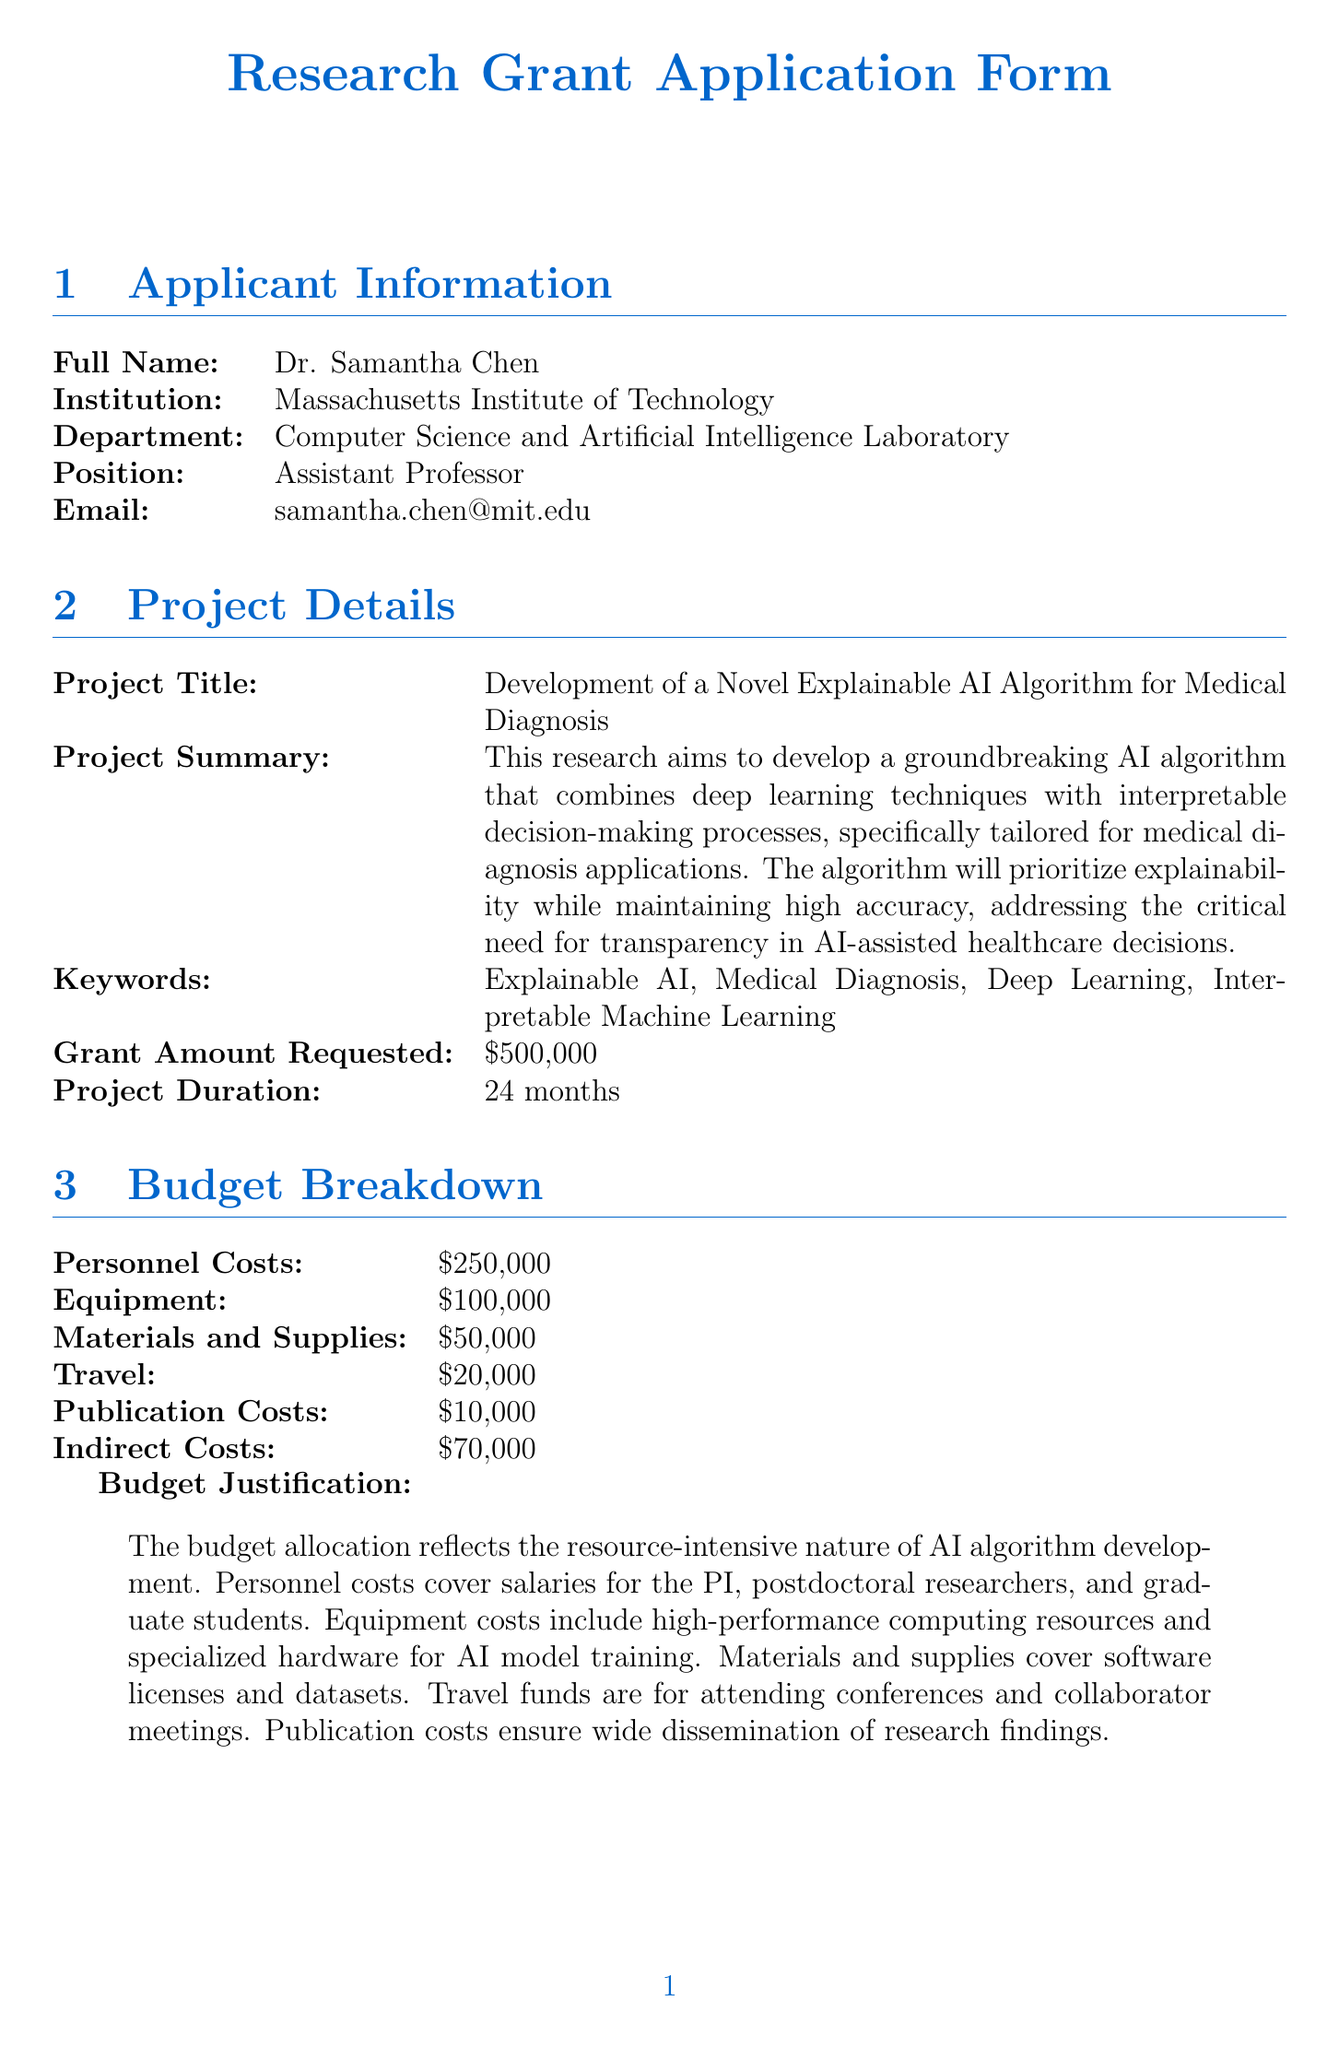what is the full name of the applicant? The full name of the applicant can be found in the "Applicant Information" section, which lists Dr. Samantha Chen.
Answer: Dr. Samantha Chen what is the project title? The project title is located in the "Project Details" section which specifies Development of a Novel Explainable AI Algorithm for Medical Diagnosis.
Answer: Development of a Novel Explainable AI Algorithm for Medical Diagnosis how much grant amount is requested? The requested grant amount is mentioned in the "Project Details" section, indicated as 500000.
Answer: 500000 how long is the project duration? Project duration is specified in the "Project Details" section and is listed as 24 months.
Answer: 24 months what are personnel costs in the budget? The personnel costs amount is found in the "Budget Breakdown" section, which shows 250000.
Answer: 250000 what is the total amount for equipment and materials and supplies? To find this total, sum the amounts for equipment and materials and supplies from the "Budget Breakdown" section, which is 100000 + 50000.
Answer: 150000 what activities are planned for month 10 to 15? The planned activities for this period are stated in the "Project Timeline" section, noting the implementation of the algorithm, initial testing, and refinement.
Answer: Implementation of the algorithm, initial testing, and refinement how many key collaborators are listed? The "Collaborators and Resources" section lists three key collaborators: Dr. Emily Zhang, Dr. Michael Johnson, and Dr. Sarah Peterson.
Answer: 3 what are the expected outcomes of the project? The expected outcomes are found in the "Expected Outcomes and Impact" section, listing four specific outcomes.
Answer: 4 